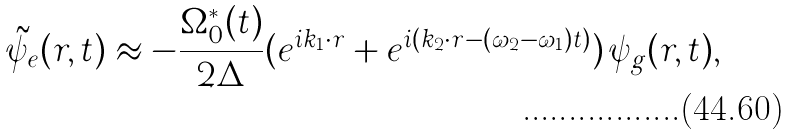Convert formula to latex. <formula><loc_0><loc_0><loc_500><loc_500>\tilde { \psi } _ { e } ( { r } , t ) \approx - \frac { \Omega _ { 0 } ^ { * } ( t ) } { 2 \Delta } ( e ^ { i { k } _ { 1 } \cdot { r } } + e ^ { i ( { k } _ { 2 } \cdot { r } - ( \omega _ { 2 } - \omega _ { 1 } ) t ) } ) \, \psi _ { g } ( { r } , t ) ,</formula> 